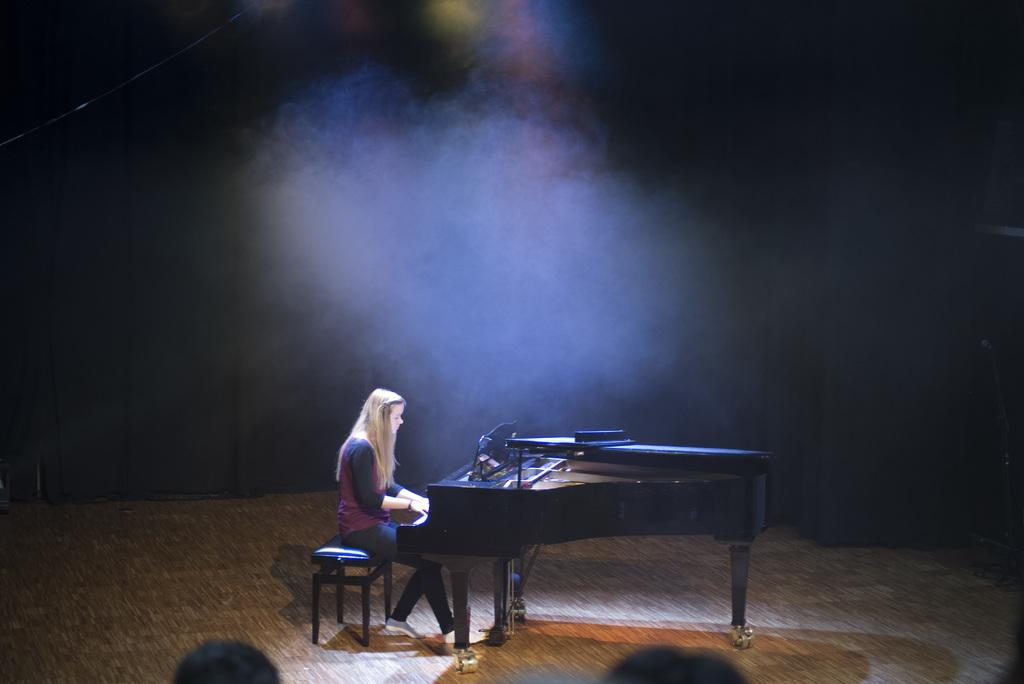Who is the main subject in the image? There is a woman in the image. What is the woman doing in the image? The woman is playing a musical keyboard. Where is the woman sitting in the image? The woman is sitting on a bench. What is the woman's opinion on the ink in the image? There is no ink present in the image, so it is not possible to determine the woman's opinion on it. 